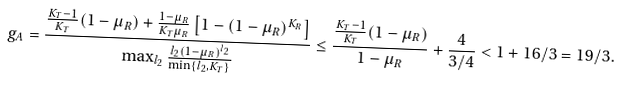<formula> <loc_0><loc_0><loc_500><loc_500>g _ { A } = \frac { \frac { K _ { T } - 1 } { K _ { T } } ( 1 - \mu _ { R } ) + \frac { 1 - \mu _ { R } } { K _ { T } \mu _ { R } } \left [ 1 - ( 1 - \mu _ { R } ) ^ { K _ { R } } \right ] } { \max _ { l _ { 2 } } \frac { l _ { 2 } ( 1 - \mu _ { R } ) ^ { l _ { 2 } } } { \min \{ l _ { 2 } , K _ { T } \} } } \leq \frac { \frac { K _ { T } - 1 } { K _ { T } } ( 1 - \mu _ { R } ) } { 1 - \mu _ { R } } + \frac { 4 } { 3 / 4 } < 1 + 1 6 / 3 = 1 9 / 3 .</formula> 